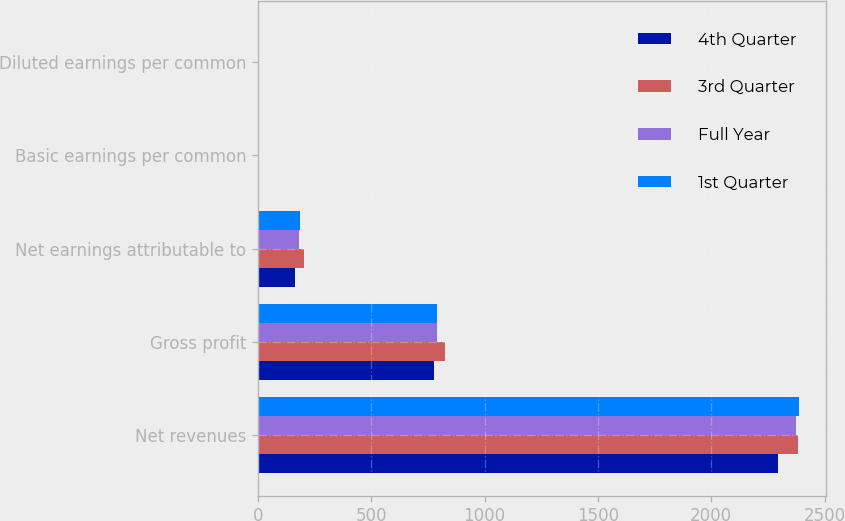Convert chart to OTSL. <chart><loc_0><loc_0><loc_500><loc_500><stacked_bar_chart><ecel><fcel>Net revenues<fcel>Gross profit<fcel>Net earnings attributable to<fcel>Basic earnings per common<fcel>Diluted earnings per common<nl><fcel>4th Quarter<fcel>2295.2<fcel>777.3<fcel>164.1<fcel>1.61<fcel>1.58<nl><fcel>3rd Quarter<fcel>2382<fcel>826.8<fcel>204.1<fcel>2<fcel>1.96<nl><fcel>Full Year<fcel>2372.7<fcel>788.4<fcel>179.5<fcel>1.74<fcel>1.71<nl><fcel>1st Quarter<fcel>2387.3<fcel>788<fcel>184.4<fcel>1.79<fcel>1.75<nl></chart> 